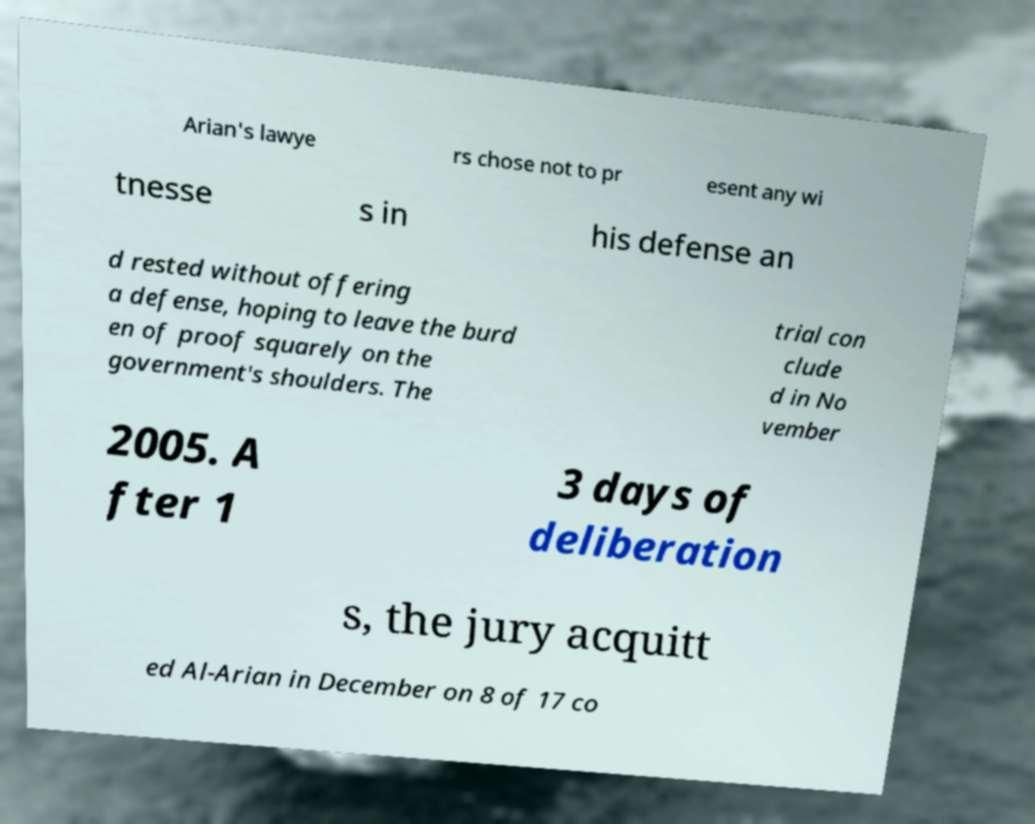Please read and relay the text visible in this image. What does it say? Arian's lawye rs chose not to pr esent any wi tnesse s in his defense an d rested without offering a defense, hoping to leave the burd en of proof squarely on the government's shoulders. The trial con clude d in No vember 2005. A fter 1 3 days of deliberation s, the jury acquitt ed Al-Arian in December on 8 of 17 co 